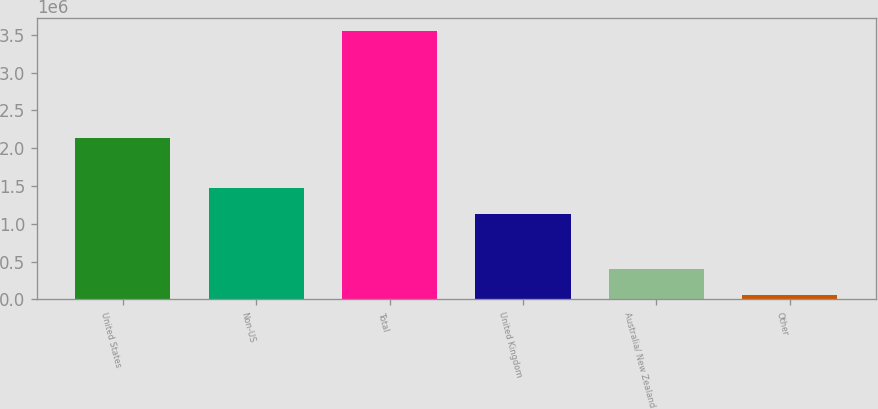<chart> <loc_0><loc_0><loc_500><loc_500><bar_chart><fcel>United States<fcel>Non-US<fcel>Total<fcel>United Kingdom<fcel>Australia/ New Zealand<fcel>Other<nl><fcel>2.13236e+06<fcel>1.47788e+06<fcel>3.55243e+06<fcel>1.12802e+06<fcel>403682<fcel>53821<nl></chart> 